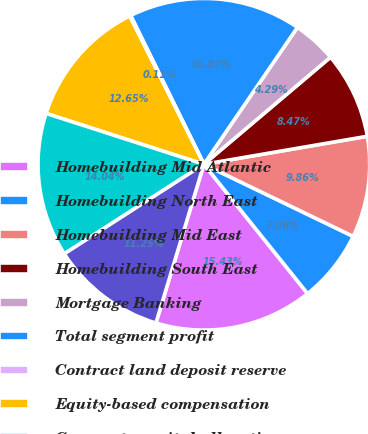Convert chart. <chart><loc_0><loc_0><loc_500><loc_500><pie_chart><fcel>Homebuilding Mid Atlantic<fcel>Homebuilding North East<fcel>Homebuilding Mid East<fcel>Homebuilding South East<fcel>Mortgage Banking<fcel>Total segment profit<fcel>Contract land deposit reserve<fcel>Equity-based compensation<fcel>Corporate capital allocation<fcel>Unallocated corporate overhead<nl><fcel>15.43%<fcel>7.08%<fcel>9.86%<fcel>8.47%<fcel>4.29%<fcel>16.82%<fcel>0.11%<fcel>12.65%<fcel>14.04%<fcel>11.25%<nl></chart> 